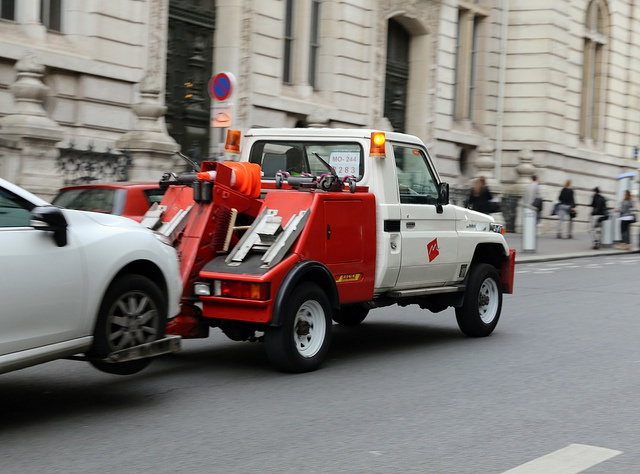Describe the objects in this image and their specific colors. I can see truck in gray, black, darkgray, and lightgray tones, car in gray, darkgray, black, and lightgray tones, people in gray, black, and darkgray tones, people in gray and black tones, and people in gray, black, and maroon tones in this image. 